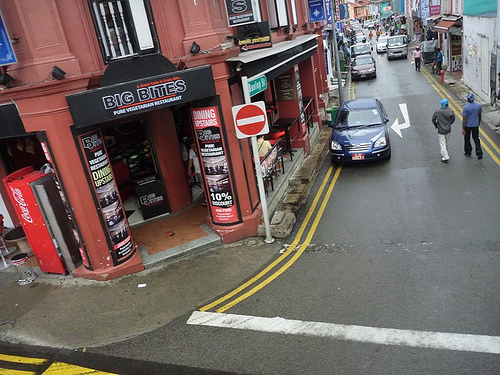<image>
Can you confirm if the sign is on the store? No. The sign is not positioned on the store. They may be near each other, but the sign is not supported by or resting on top of the store. 